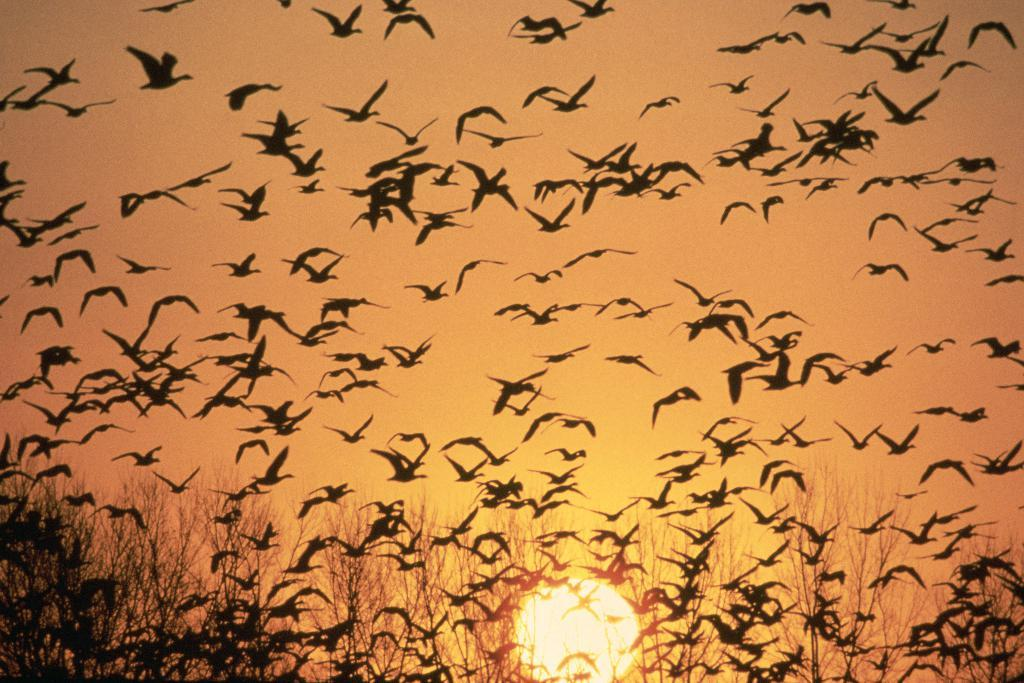What is happening in the sky in the image? There are many birds flying in the air in the image. What can be seen at the bottom of the image? There are plants at the bottom of the image. What celestial body is visible in the middle of the image? The sun is visible in the middle of the image. What is the primary background element in the image? The sky is present at the top of the image. What is the price of the leaf in the image? There is no leaf present in the image, and therefore no price can be determined. Can you solve the riddle written on the sun in the image? There is no riddle written on the sun in the image; it is a celestial body and not a surface for writing. 